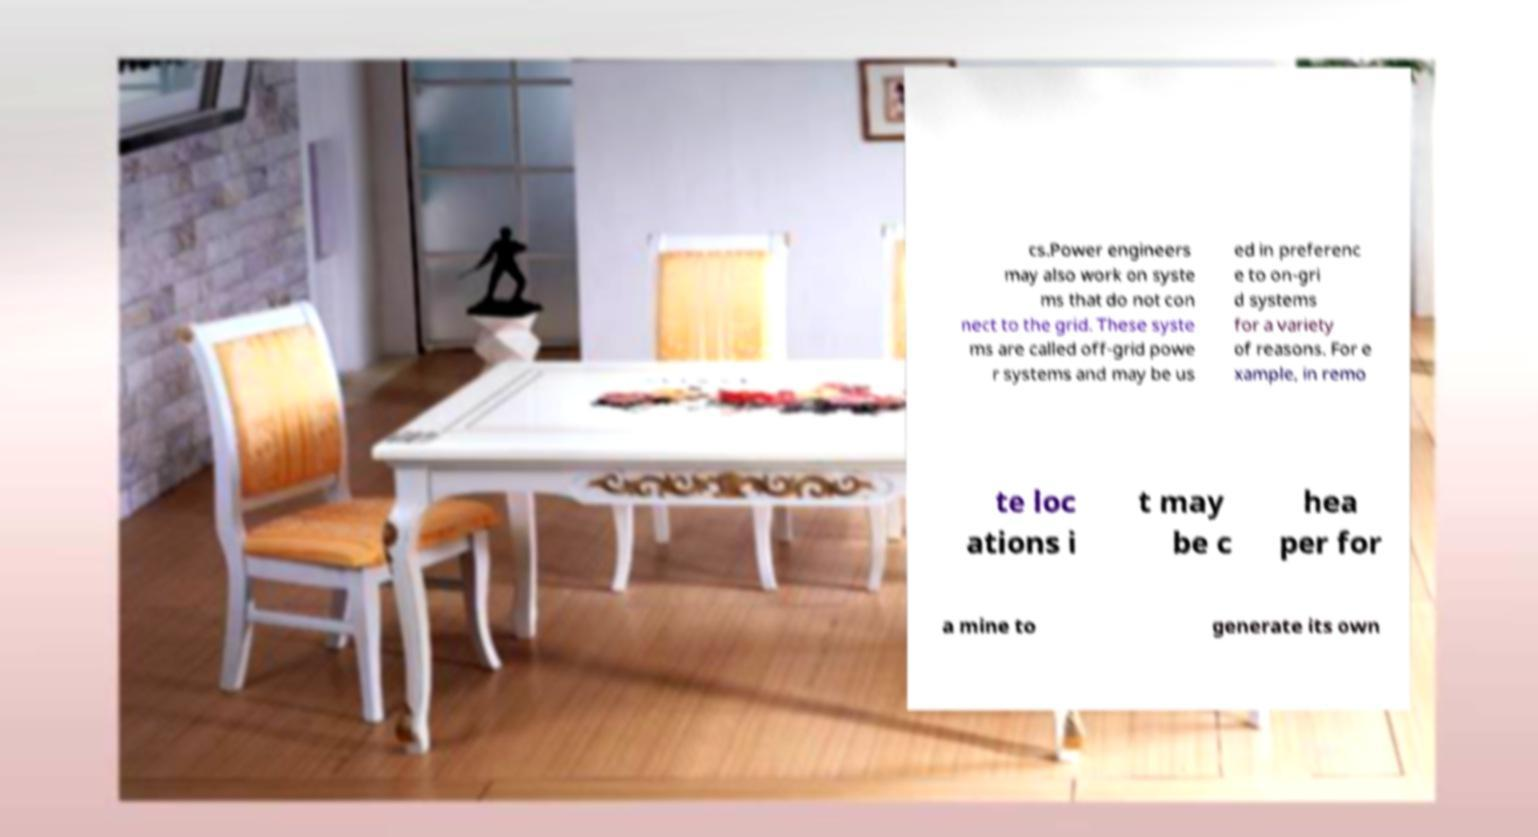I need the written content from this picture converted into text. Can you do that? cs.Power engineers may also work on syste ms that do not con nect to the grid. These syste ms are called off-grid powe r systems and may be us ed in preferenc e to on-gri d systems for a variety of reasons. For e xample, in remo te loc ations i t may be c hea per for a mine to generate its own 